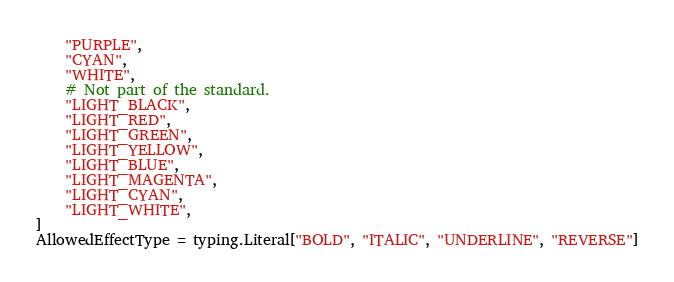Convert code to text. <code><loc_0><loc_0><loc_500><loc_500><_Python_>    "PURPLE",
    "CYAN",
    "WHITE",
    # Not part of the standard.
    "LIGHT_BLACK",
    "LIGHT_RED",
    "LIGHT_GREEN",
    "LIGHT_YELLOW",
    "LIGHT_BLUE",
    "LIGHT_MAGENTA",
    "LIGHT_CYAN",
    "LIGHT_WHITE",
]
AllowedEffectType = typing.Literal["BOLD", "ITALIC", "UNDERLINE", "REVERSE"]
</code> 